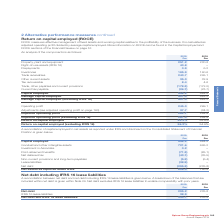According to Spirax Sarco Engineering Plc's financial document, What does ROCE measure? effective management of fixed assets and working capital relative to the profitability of the business. The document states: "d Return on capital employed (ROCE) ROCE measures effective management of fixed assets and working capital relative to the profitability of the busine..." Also, How is ROCE calculated? adjusted operating profit divided by average capital employed. The document states: "rofitability of the business. It is calculated as adjusted operating profit divided by average capital employed. More information on ROCE can be found..." Also, What are the components factored in when calculating the adjusted operating profit? The document shows two values: Operating profit and Adjustments. From the document: "Operating profit 245.0 299.1 Adjustments (see adjusted operating profit on page 160) 37.7 (34.2) Adjusted operating Operating profit 245.0 299.1 Adjus..." Additionally, In which year was the amount of other current assets larger? According to the financial document, 2019. The relevant text states: "Annual Report 2019..." Also, can you calculate: What was the change in the adjusted operating profit in 2019 from 2018? Based on the calculation: 282.7-264.9, the result is 17.8 (in millions). This is based on the information: "160) 37.7 (34.2) Adjusted operating profit 282.7 264.9 Adjusted operating profit (excluding IFRS 16) 281.4 264.9 Return on capital employed 54.2% 54.9% Re n page 160) 37.7 (34.2) Adjusted operating pr..." The key data points involved are: 264.9, 282.7. Also, can you calculate: What was the percentage change in the adjusted operating profit in 2019 from 2018? To answer this question, I need to perform calculations using the financial data. The calculation is: (282.7-264.9)/264.9, which equals 6.72 (percentage). This is based on the information: "160) 37.7 (34.2) Adjusted operating profit 282.7 264.9 Adjusted operating profit (excluding IFRS 16) 281.4 264.9 Return on capital employed 54.2% 54.9% Re n page 160) 37.7 (34.2) Adjusted operating pr..." The key data points involved are: 264.9, 282.7. 